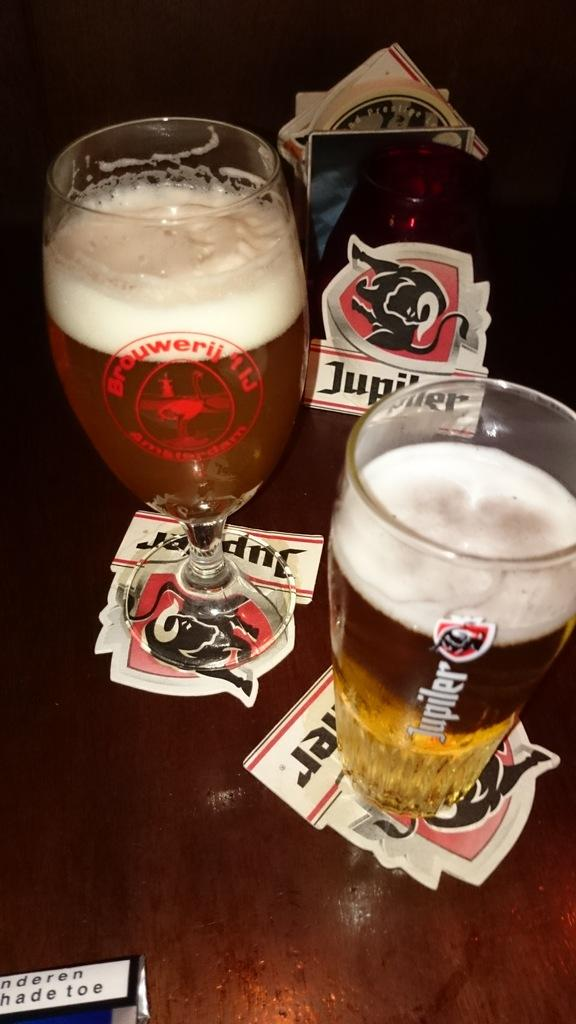<image>
Offer a succinct explanation of the picture presented. Two mugs of foamy beer sit atop Jupiter label shaped coasters. 